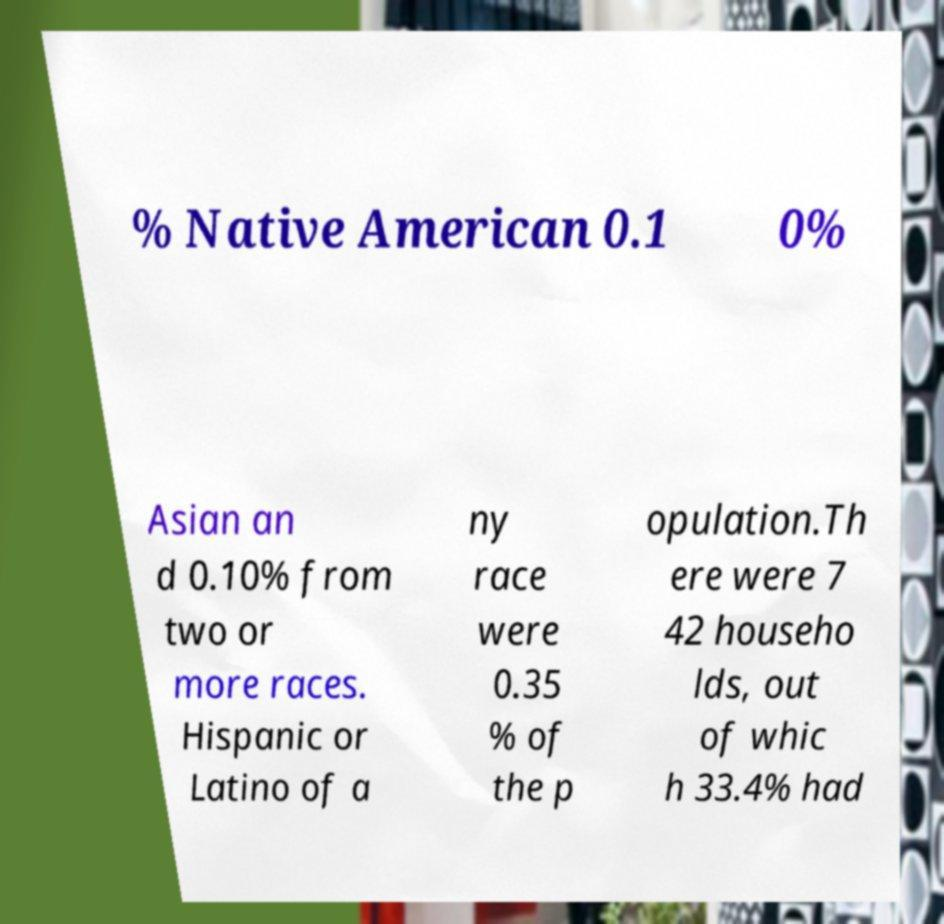Can you accurately transcribe the text from the provided image for me? % Native American 0.1 0% Asian an d 0.10% from two or more races. Hispanic or Latino of a ny race were 0.35 % of the p opulation.Th ere were 7 42 househo lds, out of whic h 33.4% had 